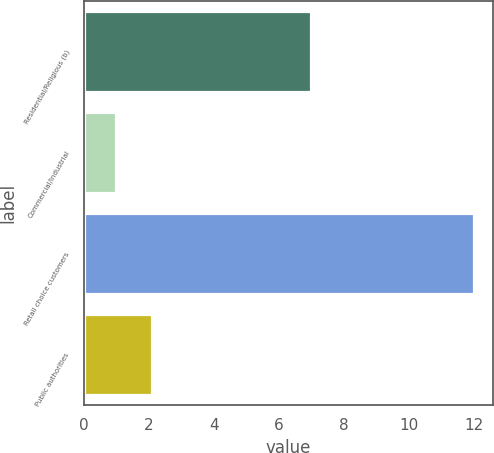Convert chart to OTSL. <chart><loc_0><loc_0><loc_500><loc_500><bar_chart><fcel>Residential/Religious (b)<fcel>Commercial/Industrial<fcel>Retail choice customers<fcel>Public authorities<nl><fcel>7<fcel>1<fcel>12<fcel>2.1<nl></chart> 